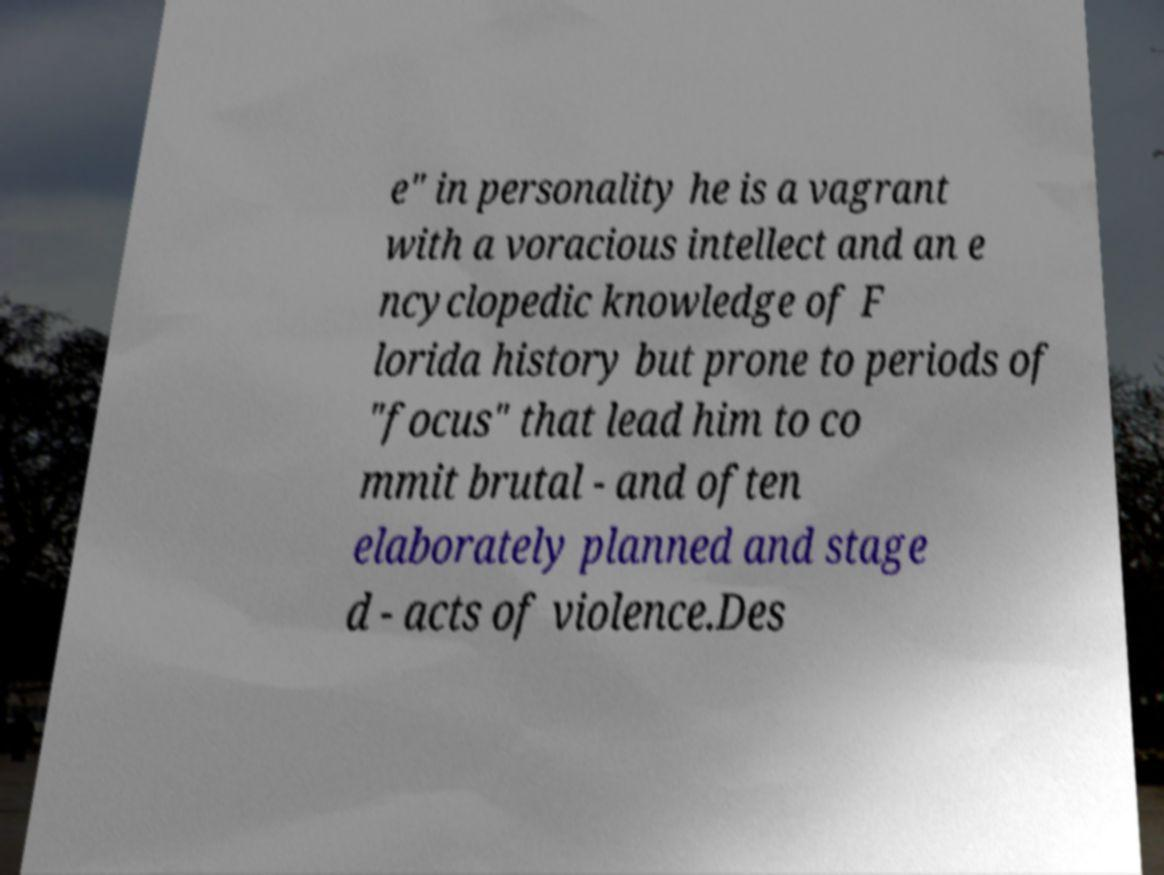Can you accurately transcribe the text from the provided image for me? e" in personality he is a vagrant with a voracious intellect and an e ncyclopedic knowledge of F lorida history but prone to periods of "focus" that lead him to co mmit brutal - and often elaborately planned and stage d - acts of violence.Des 